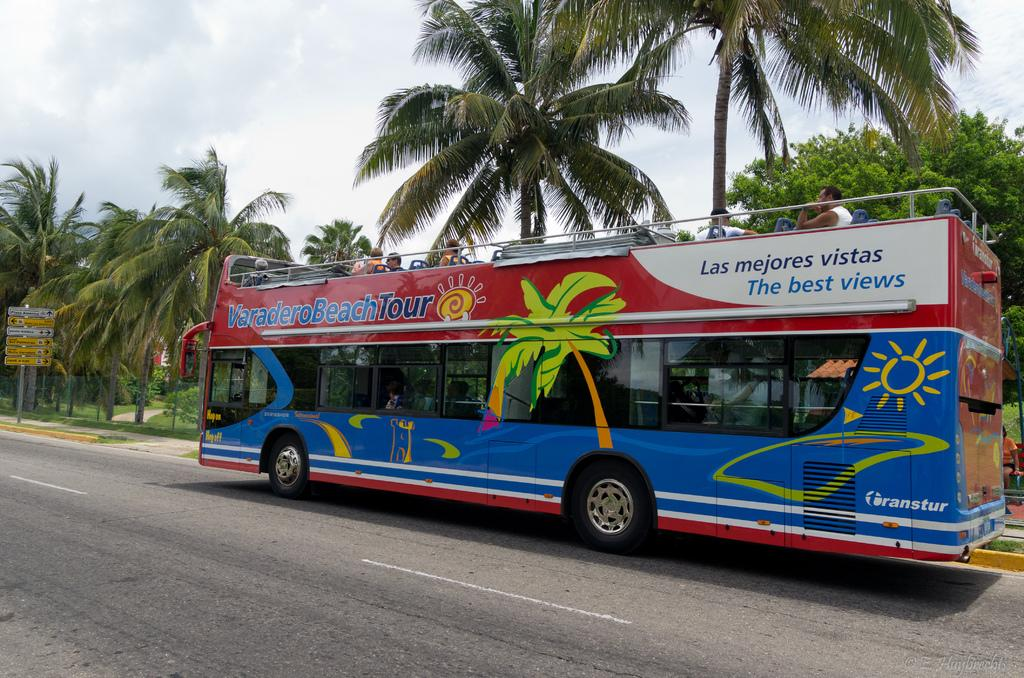<image>
Share a concise interpretation of the image provided. A double-decker bus gives people the Varadero beach tour. 